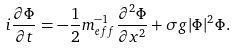Convert formula to latex. <formula><loc_0><loc_0><loc_500><loc_500>i \frac { \partial \Phi } { \partial t } = - \frac { 1 } { 2 } m _ { e f f } ^ { - 1 } \frac { \partial ^ { 2 } \Phi } { \partial x ^ { 2 } } + \sigma g | \Phi | ^ { 2 } \Phi .</formula> 